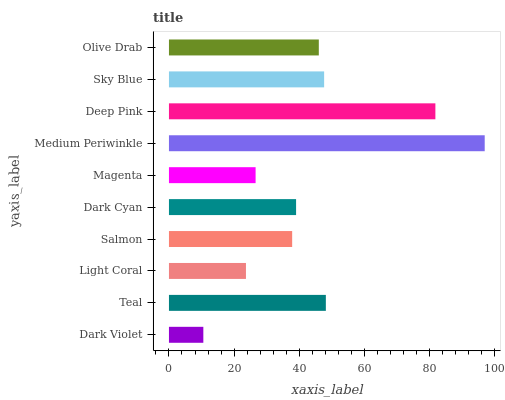Is Dark Violet the minimum?
Answer yes or no. Yes. Is Medium Periwinkle the maximum?
Answer yes or no. Yes. Is Teal the minimum?
Answer yes or no. No. Is Teal the maximum?
Answer yes or no. No. Is Teal greater than Dark Violet?
Answer yes or no. Yes. Is Dark Violet less than Teal?
Answer yes or no. Yes. Is Dark Violet greater than Teal?
Answer yes or no. No. Is Teal less than Dark Violet?
Answer yes or no. No. Is Olive Drab the high median?
Answer yes or no. Yes. Is Dark Cyan the low median?
Answer yes or no. Yes. Is Dark Cyan the high median?
Answer yes or no. No. Is Medium Periwinkle the low median?
Answer yes or no. No. 